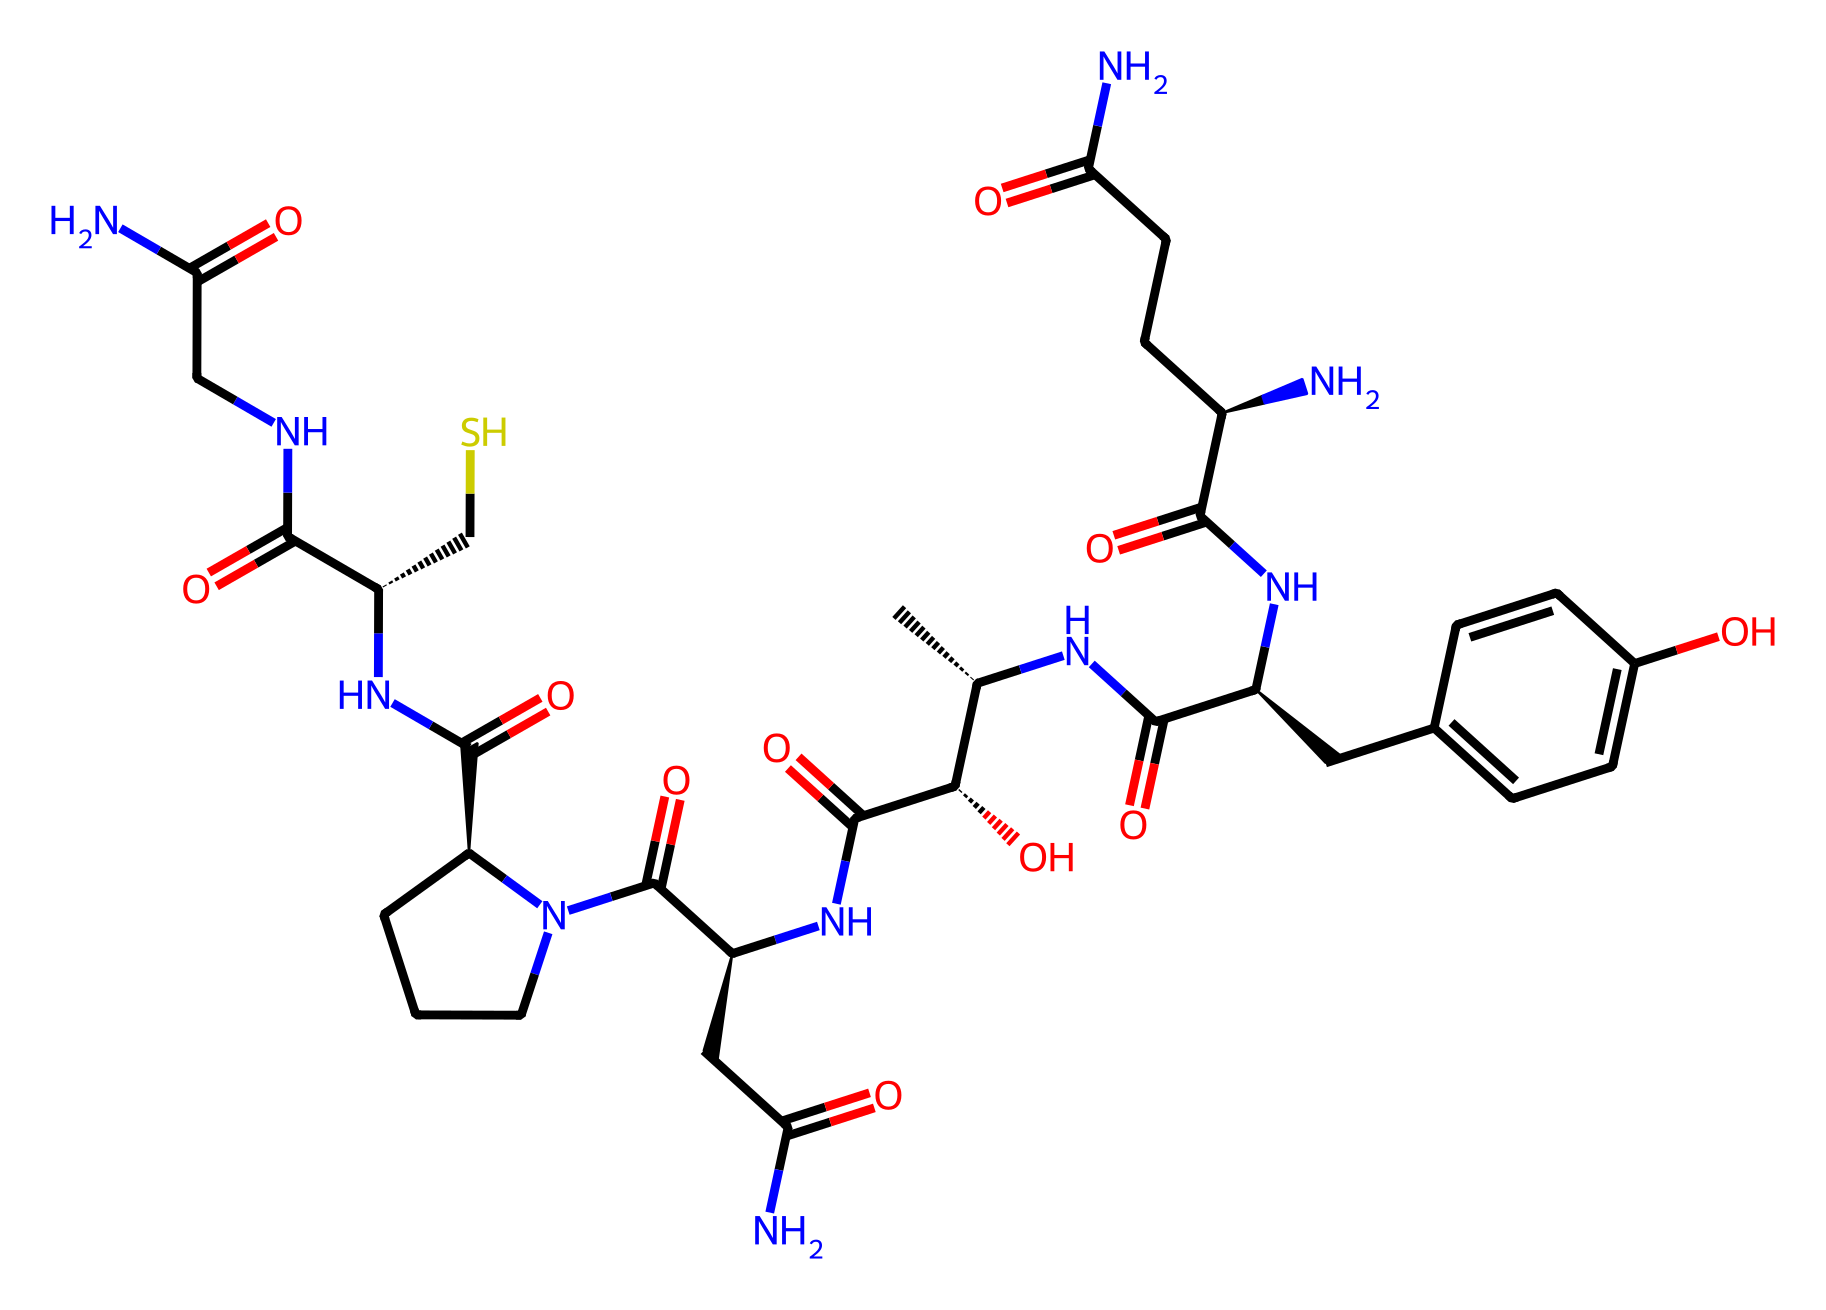What is the molecular formula of this oxytocin derivative? To determine the molecular formula, count the total number of each type of atom in the SMILES representation. This involves identifying carbon (C), hydrogen (H), nitrogen (N), and oxygen (O) atoms. The total is C43, H60, N10, O10.
Answer: C43H60N10O10 How many nitrogen atoms are present in the structure? By analyzing the SMILES, we can see several occurrences of nitrogen atoms (N). There are 10 instances of nitrogen in the representation.
Answer: 10 Which functional groups are present in this molecule? Examine the structure for specific groups. Notably, the molecule contains amides (C(=O)N), hydroxyl groups (C(=O)N[C@@H](CS)C(=O)N), and phenolic hydroxyl groups (CC1=CC=C(O)C=C1). This indicates multiple functional groups like amides, alcohols, and phenols.
Answer: amides, alcohols, phenols What type of coordination is likely to occur in oxytocin based on its nitrogen atoms? The presence of nitrogen atoms suggests that oxytocin has the potential to engage in coordination bonds through its amide groups and possibly interact with metals, hinting at the capability for chelation.
Answer: chelation Does this molecule conform to a specific chiral configuration? The presence of @ symbols in the SMILES indicates the presence of chiral centers. Specifically, the molecule exhibits different configurations at least four centers, which are specified in the structure.
Answer: yes 